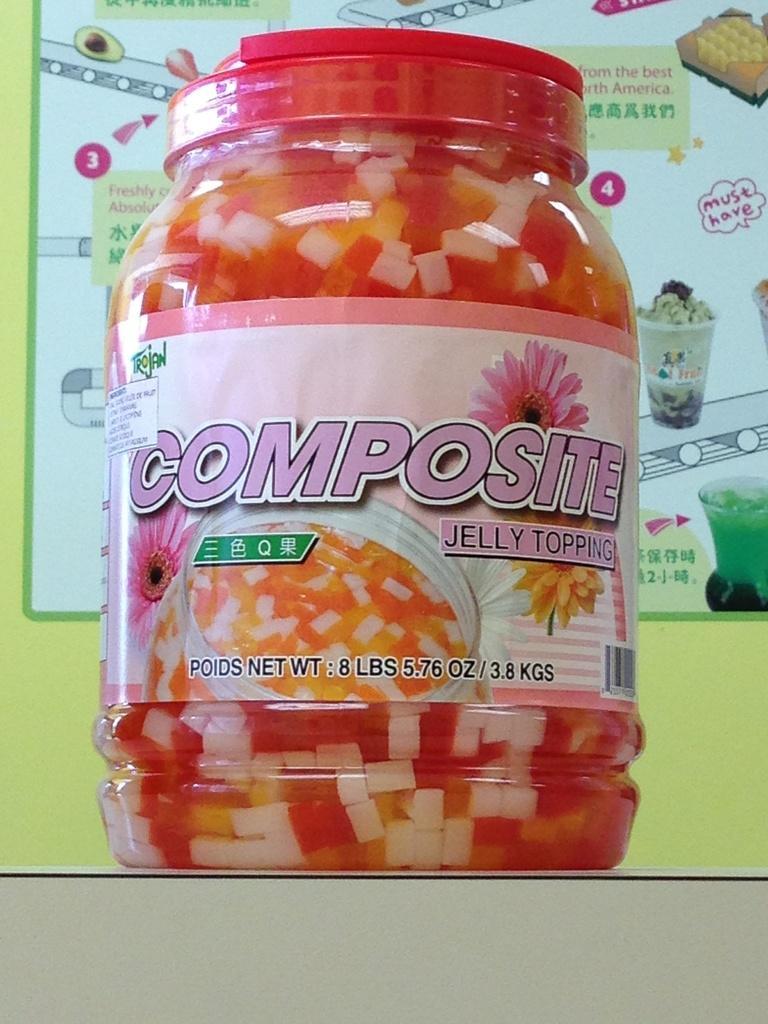Describe this image in one or two sentences. In this image we can see a container with a lid with some food inside it which is placed on the surface. 